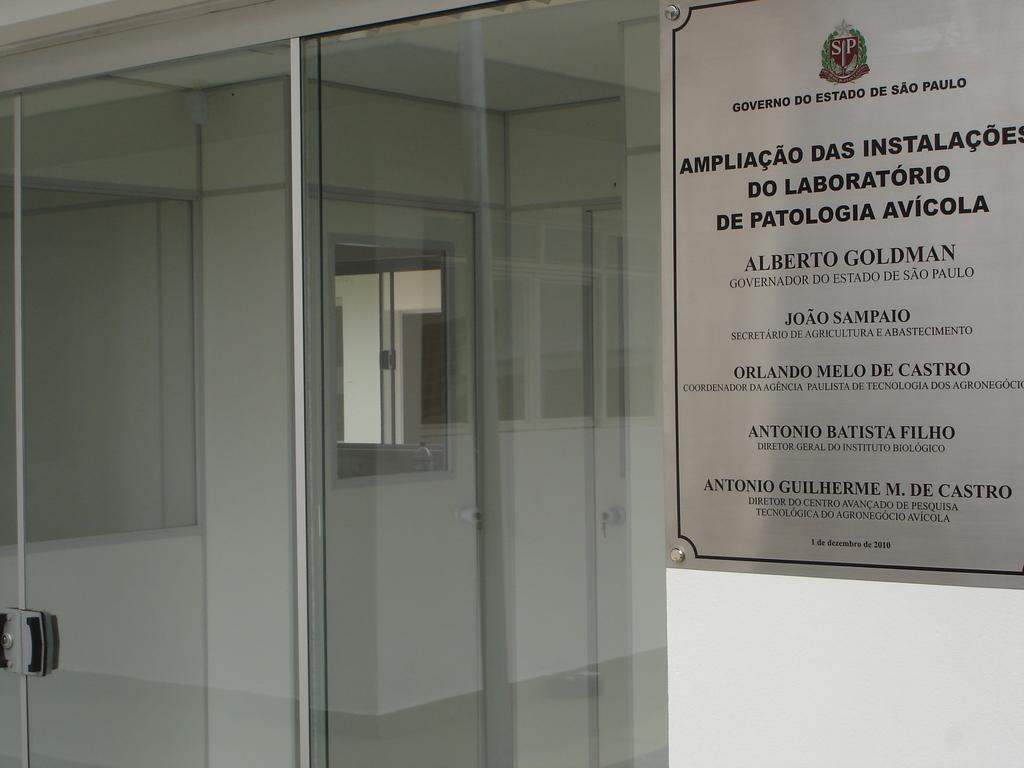<image>
Present a compact description of the photo's key features. an office exterior with a sign for Governo Do Estado De Sao Paulo 